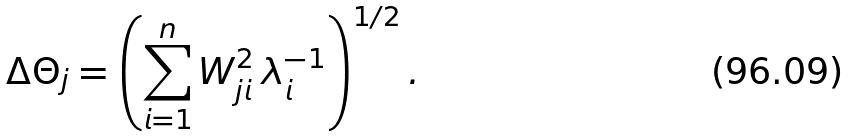Convert formula to latex. <formula><loc_0><loc_0><loc_500><loc_500>\Delta \Theta _ { j } = \left ( \sum _ { i = 1 } ^ { n } W _ { j i } ^ { 2 } \, \lambda _ { i } ^ { - 1 } \right ) ^ { 1 / 2 } .</formula> 